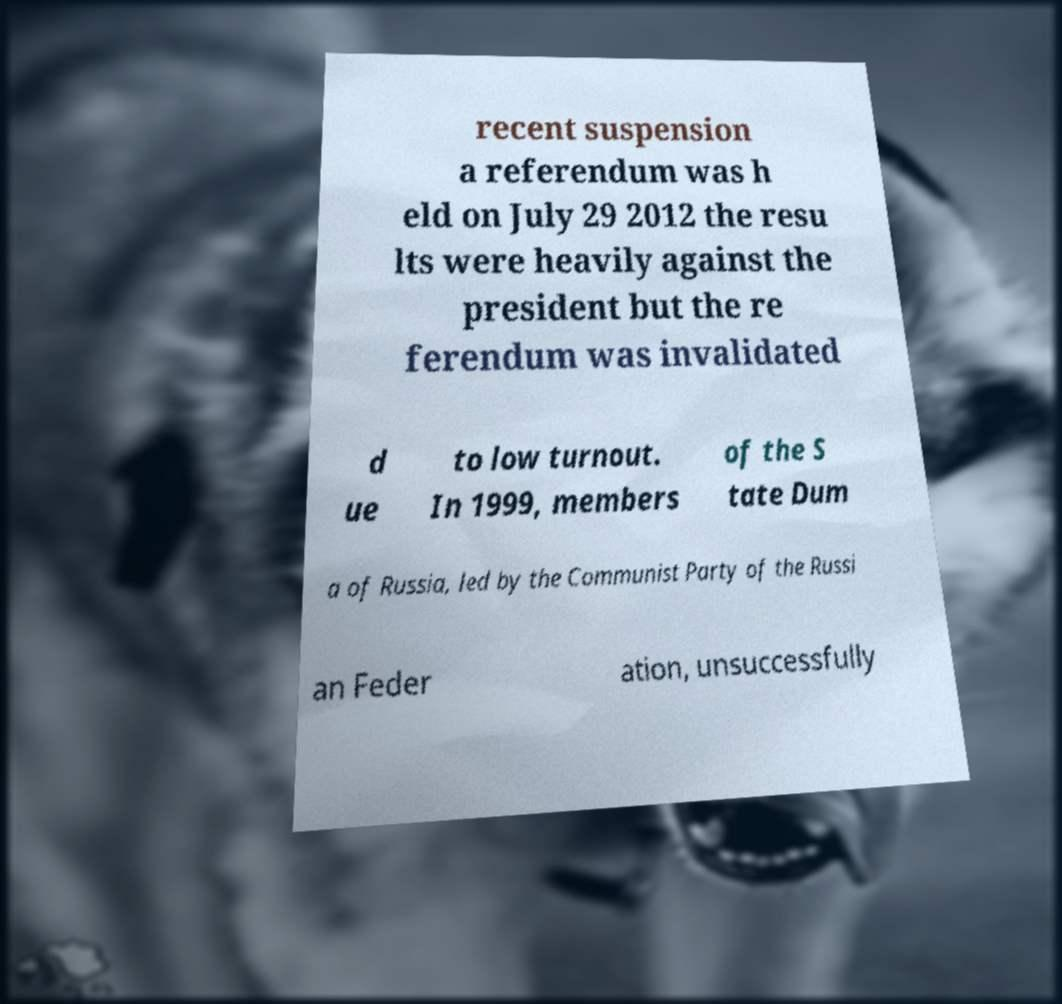Can you accurately transcribe the text from the provided image for me? recent suspension a referendum was h eld on July 29 2012 the resu lts were heavily against the president but the re ferendum was invalidated d ue to low turnout. In 1999, members of the S tate Dum a of Russia, led by the Communist Party of the Russi an Feder ation, unsuccessfully 